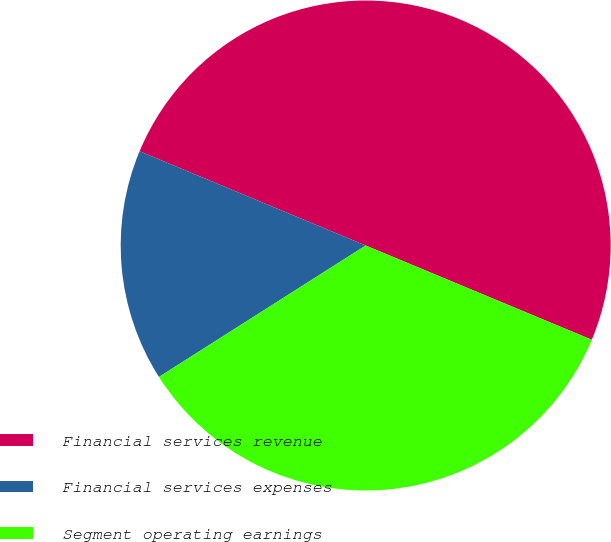Convert chart to OTSL. <chart><loc_0><loc_0><loc_500><loc_500><pie_chart><fcel>Financial services revenue<fcel>Financial services expenses<fcel>Segment operating earnings<nl><fcel>50.0%<fcel>15.3%<fcel>34.7%<nl></chart> 